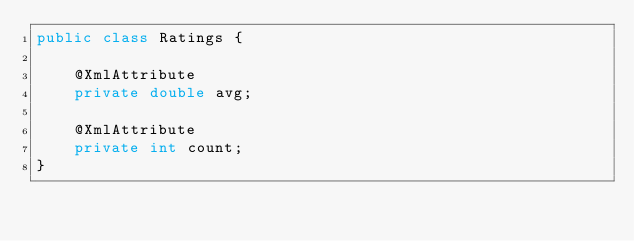<code> <loc_0><loc_0><loc_500><loc_500><_Java_>public class Ratings {

    @XmlAttribute
    private double avg;

    @XmlAttribute
    private int count;
}
</code> 